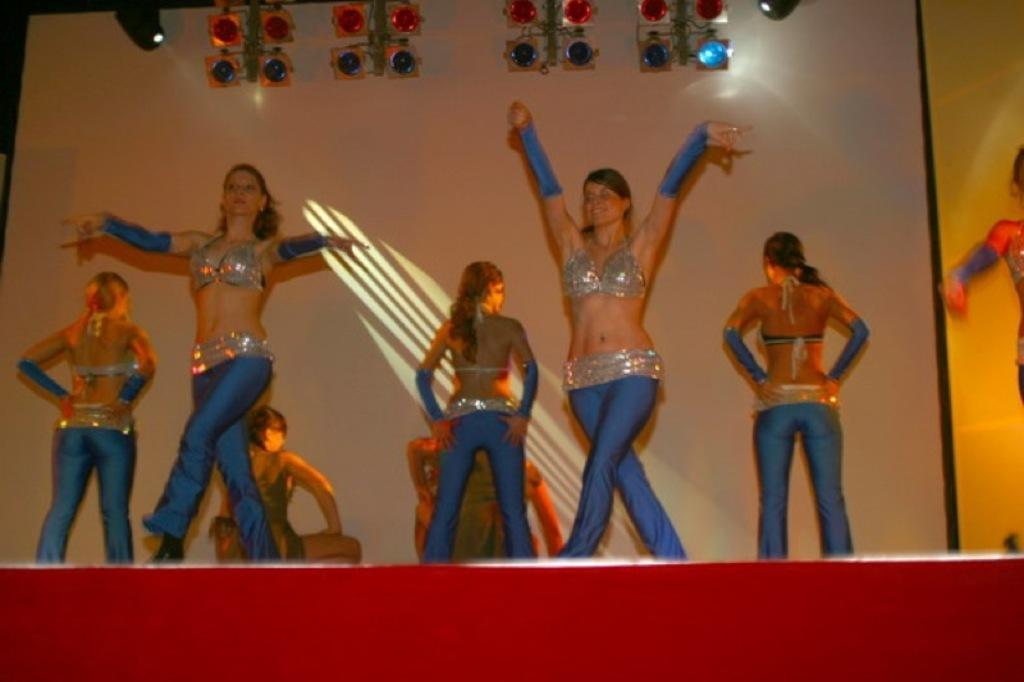What are the people in the image doing? The people in the image are dancing. What can be seen illuminating the scene in the image? There are lights visible in the image. What device is used to project images or videos in the image? A projector is present in the image. What surface are the people dancing on in the image? There is a stage in the image. What type of wood is used to build the gate in the image? There is no gate present in the image; it features people dancing, lights, a projector, and a stage. What material is the silk curtain made of in the image? There is no silk curtain present in the image. 